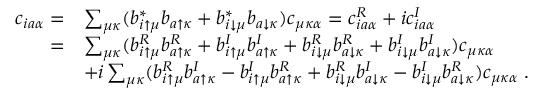<formula> <loc_0><loc_0><loc_500><loc_500>\begin{array} { r l } { c _ { i a \alpha } = } & { \sum _ { \mu \kappa } ( b _ { i \uparrow \mu } ^ { * } b _ { a \uparrow \kappa } + b _ { i \downarrow \mu } ^ { * } b _ { a \downarrow \kappa } ) c _ { \mu \kappa \alpha } = c _ { i a \alpha } ^ { R } + i c _ { i a \alpha } ^ { I } } \\ { = } & { \sum _ { \mu \kappa } ( b _ { i \uparrow \mu } ^ { R } b _ { a \uparrow \kappa } ^ { R } + b _ { i \uparrow \mu } ^ { I } b _ { a \uparrow \kappa } ^ { I } + b _ { i \downarrow \mu } ^ { R } b _ { a \downarrow \kappa } ^ { R } + b _ { i \downarrow \mu } ^ { I } b _ { a \downarrow \kappa } ^ { I } ) c _ { \mu \kappa \alpha } } \\ & { + i \sum _ { \mu \kappa } ( b _ { i \uparrow \mu } ^ { R } b _ { a \uparrow \kappa } ^ { I } - b _ { i \uparrow \mu } ^ { I } b _ { a \uparrow \kappa } ^ { R } + b _ { i \downarrow \mu } ^ { R } b _ { a \downarrow \kappa } ^ { I } - b _ { i \downarrow \mu } ^ { I } b _ { a \downarrow \kappa } ^ { R } ) c _ { \mu \kappa \alpha } \, . } \end{array}</formula> 